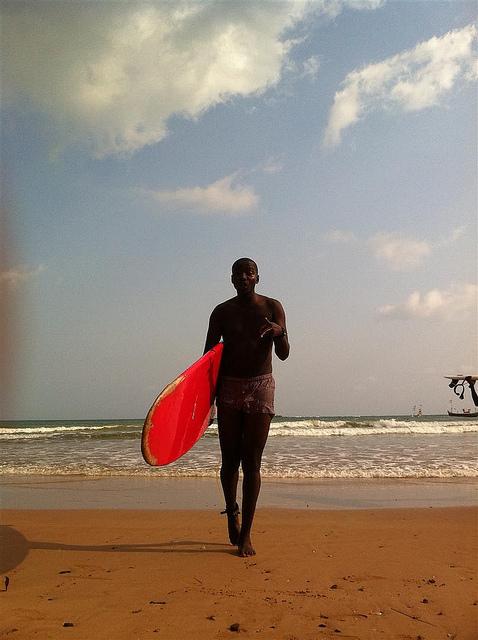What location is in the picture?
Give a very brief answer. Beach. How many boards in the photo?
Keep it brief. 1. Where is the surfboard?
Concise answer only. Underarm. What is the man wearing?
Quick response, please. Shorts. Is he in the water?
Quick response, please. No. What is on the man's ears?
Short answer required. Nothing. Which way is the surfer headed?
Be succinct. North. Is the man wearing a wetsuit?
Answer briefly. No. What color is the surfboard?
Short answer required. Red. Is this a sunny day?
Answer briefly. Yes. 